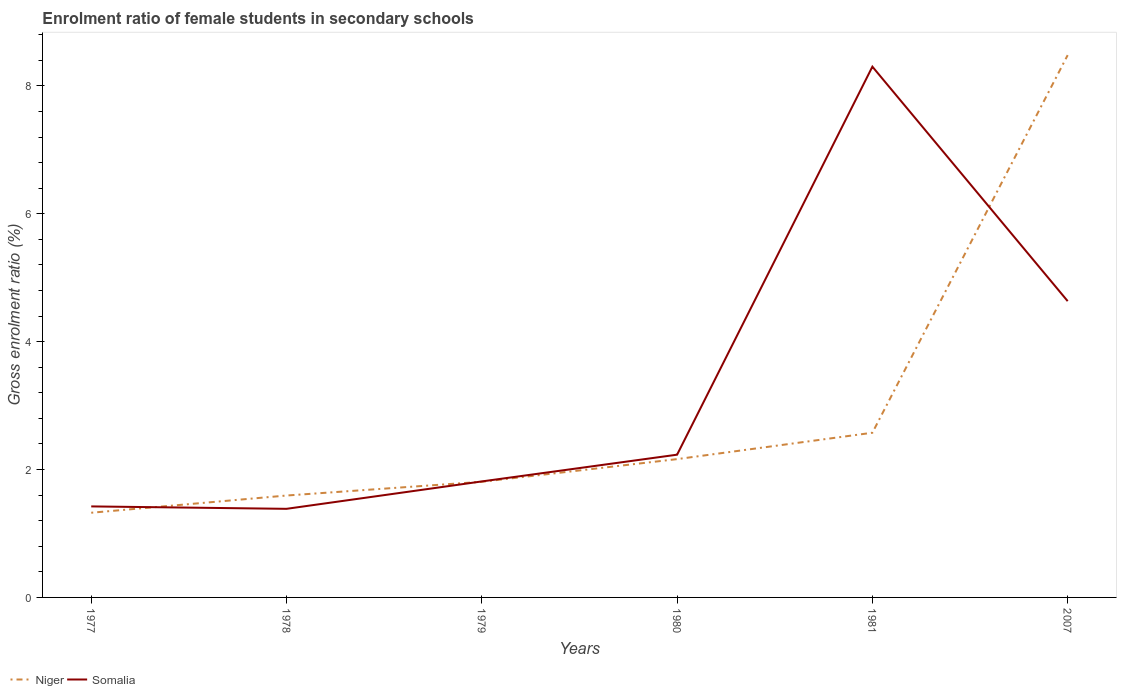Is the number of lines equal to the number of legend labels?
Your response must be concise. Yes. Across all years, what is the maximum enrolment ratio of female students in secondary schools in Niger?
Offer a terse response. 1.32. In which year was the enrolment ratio of female students in secondary schools in Somalia maximum?
Ensure brevity in your answer.  1978. What is the total enrolment ratio of female students in secondary schools in Somalia in the graph?
Offer a terse response. -0.43. What is the difference between the highest and the second highest enrolment ratio of female students in secondary schools in Niger?
Make the answer very short. 7.16. What is the difference between two consecutive major ticks on the Y-axis?
Your answer should be compact. 2. Does the graph contain grids?
Your answer should be very brief. No. How are the legend labels stacked?
Your response must be concise. Horizontal. What is the title of the graph?
Offer a terse response. Enrolment ratio of female students in secondary schools. What is the label or title of the X-axis?
Keep it short and to the point. Years. What is the label or title of the Y-axis?
Offer a very short reply. Gross enrolment ratio (%). What is the Gross enrolment ratio (%) of Niger in 1977?
Offer a terse response. 1.32. What is the Gross enrolment ratio (%) in Somalia in 1977?
Give a very brief answer. 1.42. What is the Gross enrolment ratio (%) in Niger in 1978?
Provide a succinct answer. 1.59. What is the Gross enrolment ratio (%) in Somalia in 1978?
Your answer should be very brief. 1.39. What is the Gross enrolment ratio (%) in Niger in 1979?
Your response must be concise. 1.81. What is the Gross enrolment ratio (%) of Somalia in 1979?
Provide a succinct answer. 1.81. What is the Gross enrolment ratio (%) in Niger in 1980?
Ensure brevity in your answer.  2.16. What is the Gross enrolment ratio (%) in Somalia in 1980?
Your answer should be compact. 2.23. What is the Gross enrolment ratio (%) of Niger in 1981?
Your answer should be compact. 2.58. What is the Gross enrolment ratio (%) in Somalia in 1981?
Give a very brief answer. 8.3. What is the Gross enrolment ratio (%) of Niger in 2007?
Give a very brief answer. 8.48. What is the Gross enrolment ratio (%) in Somalia in 2007?
Your answer should be very brief. 4.63. Across all years, what is the maximum Gross enrolment ratio (%) in Niger?
Ensure brevity in your answer.  8.48. Across all years, what is the maximum Gross enrolment ratio (%) in Somalia?
Your response must be concise. 8.3. Across all years, what is the minimum Gross enrolment ratio (%) of Niger?
Provide a short and direct response. 1.32. Across all years, what is the minimum Gross enrolment ratio (%) of Somalia?
Make the answer very short. 1.39. What is the total Gross enrolment ratio (%) in Niger in the graph?
Your answer should be very brief. 17.95. What is the total Gross enrolment ratio (%) of Somalia in the graph?
Provide a succinct answer. 19.79. What is the difference between the Gross enrolment ratio (%) in Niger in 1977 and that in 1978?
Offer a very short reply. -0.27. What is the difference between the Gross enrolment ratio (%) of Somalia in 1977 and that in 1978?
Offer a terse response. 0.04. What is the difference between the Gross enrolment ratio (%) of Niger in 1977 and that in 1979?
Make the answer very short. -0.48. What is the difference between the Gross enrolment ratio (%) in Somalia in 1977 and that in 1979?
Make the answer very short. -0.39. What is the difference between the Gross enrolment ratio (%) in Niger in 1977 and that in 1980?
Provide a succinct answer. -0.84. What is the difference between the Gross enrolment ratio (%) in Somalia in 1977 and that in 1980?
Offer a very short reply. -0.81. What is the difference between the Gross enrolment ratio (%) of Niger in 1977 and that in 1981?
Ensure brevity in your answer.  -1.25. What is the difference between the Gross enrolment ratio (%) of Somalia in 1977 and that in 1981?
Offer a very short reply. -6.88. What is the difference between the Gross enrolment ratio (%) in Niger in 1977 and that in 2007?
Your response must be concise. -7.16. What is the difference between the Gross enrolment ratio (%) of Somalia in 1977 and that in 2007?
Your response must be concise. -3.21. What is the difference between the Gross enrolment ratio (%) in Niger in 1978 and that in 1979?
Make the answer very short. -0.21. What is the difference between the Gross enrolment ratio (%) in Somalia in 1978 and that in 1979?
Your answer should be very brief. -0.43. What is the difference between the Gross enrolment ratio (%) of Niger in 1978 and that in 1980?
Make the answer very short. -0.57. What is the difference between the Gross enrolment ratio (%) of Somalia in 1978 and that in 1980?
Provide a succinct answer. -0.85. What is the difference between the Gross enrolment ratio (%) in Niger in 1978 and that in 1981?
Give a very brief answer. -0.98. What is the difference between the Gross enrolment ratio (%) of Somalia in 1978 and that in 1981?
Give a very brief answer. -6.92. What is the difference between the Gross enrolment ratio (%) of Niger in 1978 and that in 2007?
Your response must be concise. -6.89. What is the difference between the Gross enrolment ratio (%) in Somalia in 1978 and that in 2007?
Give a very brief answer. -3.25. What is the difference between the Gross enrolment ratio (%) of Niger in 1979 and that in 1980?
Your response must be concise. -0.35. What is the difference between the Gross enrolment ratio (%) in Somalia in 1979 and that in 1980?
Make the answer very short. -0.42. What is the difference between the Gross enrolment ratio (%) in Niger in 1979 and that in 1981?
Give a very brief answer. -0.77. What is the difference between the Gross enrolment ratio (%) in Somalia in 1979 and that in 1981?
Offer a very short reply. -6.49. What is the difference between the Gross enrolment ratio (%) in Niger in 1979 and that in 2007?
Ensure brevity in your answer.  -6.67. What is the difference between the Gross enrolment ratio (%) of Somalia in 1979 and that in 2007?
Offer a terse response. -2.82. What is the difference between the Gross enrolment ratio (%) of Niger in 1980 and that in 1981?
Make the answer very short. -0.41. What is the difference between the Gross enrolment ratio (%) in Somalia in 1980 and that in 1981?
Offer a very short reply. -6.07. What is the difference between the Gross enrolment ratio (%) in Niger in 1980 and that in 2007?
Ensure brevity in your answer.  -6.32. What is the difference between the Gross enrolment ratio (%) of Somalia in 1980 and that in 2007?
Provide a succinct answer. -2.4. What is the difference between the Gross enrolment ratio (%) of Niger in 1981 and that in 2007?
Provide a short and direct response. -5.91. What is the difference between the Gross enrolment ratio (%) in Somalia in 1981 and that in 2007?
Your response must be concise. 3.67. What is the difference between the Gross enrolment ratio (%) of Niger in 1977 and the Gross enrolment ratio (%) of Somalia in 1978?
Keep it short and to the point. -0.06. What is the difference between the Gross enrolment ratio (%) of Niger in 1977 and the Gross enrolment ratio (%) of Somalia in 1979?
Offer a very short reply. -0.49. What is the difference between the Gross enrolment ratio (%) in Niger in 1977 and the Gross enrolment ratio (%) in Somalia in 1980?
Offer a terse response. -0.91. What is the difference between the Gross enrolment ratio (%) of Niger in 1977 and the Gross enrolment ratio (%) of Somalia in 1981?
Provide a succinct answer. -6.98. What is the difference between the Gross enrolment ratio (%) in Niger in 1977 and the Gross enrolment ratio (%) in Somalia in 2007?
Offer a terse response. -3.31. What is the difference between the Gross enrolment ratio (%) of Niger in 1978 and the Gross enrolment ratio (%) of Somalia in 1979?
Make the answer very short. -0.22. What is the difference between the Gross enrolment ratio (%) of Niger in 1978 and the Gross enrolment ratio (%) of Somalia in 1980?
Provide a short and direct response. -0.64. What is the difference between the Gross enrolment ratio (%) in Niger in 1978 and the Gross enrolment ratio (%) in Somalia in 1981?
Keep it short and to the point. -6.71. What is the difference between the Gross enrolment ratio (%) in Niger in 1978 and the Gross enrolment ratio (%) in Somalia in 2007?
Provide a short and direct response. -3.04. What is the difference between the Gross enrolment ratio (%) in Niger in 1979 and the Gross enrolment ratio (%) in Somalia in 1980?
Your answer should be very brief. -0.42. What is the difference between the Gross enrolment ratio (%) of Niger in 1979 and the Gross enrolment ratio (%) of Somalia in 1981?
Your answer should be very brief. -6.49. What is the difference between the Gross enrolment ratio (%) in Niger in 1979 and the Gross enrolment ratio (%) in Somalia in 2007?
Ensure brevity in your answer.  -2.83. What is the difference between the Gross enrolment ratio (%) of Niger in 1980 and the Gross enrolment ratio (%) of Somalia in 1981?
Your response must be concise. -6.14. What is the difference between the Gross enrolment ratio (%) in Niger in 1980 and the Gross enrolment ratio (%) in Somalia in 2007?
Provide a succinct answer. -2.47. What is the difference between the Gross enrolment ratio (%) of Niger in 1981 and the Gross enrolment ratio (%) of Somalia in 2007?
Make the answer very short. -2.06. What is the average Gross enrolment ratio (%) in Niger per year?
Keep it short and to the point. 2.99. What is the average Gross enrolment ratio (%) in Somalia per year?
Provide a succinct answer. 3.3. In the year 1977, what is the difference between the Gross enrolment ratio (%) in Niger and Gross enrolment ratio (%) in Somalia?
Offer a terse response. -0.1. In the year 1978, what is the difference between the Gross enrolment ratio (%) of Niger and Gross enrolment ratio (%) of Somalia?
Keep it short and to the point. 0.21. In the year 1979, what is the difference between the Gross enrolment ratio (%) in Niger and Gross enrolment ratio (%) in Somalia?
Give a very brief answer. -0.01. In the year 1980, what is the difference between the Gross enrolment ratio (%) in Niger and Gross enrolment ratio (%) in Somalia?
Your answer should be compact. -0.07. In the year 1981, what is the difference between the Gross enrolment ratio (%) of Niger and Gross enrolment ratio (%) of Somalia?
Keep it short and to the point. -5.73. In the year 2007, what is the difference between the Gross enrolment ratio (%) of Niger and Gross enrolment ratio (%) of Somalia?
Keep it short and to the point. 3.85. What is the ratio of the Gross enrolment ratio (%) of Niger in 1977 to that in 1978?
Ensure brevity in your answer.  0.83. What is the ratio of the Gross enrolment ratio (%) of Somalia in 1977 to that in 1978?
Your answer should be very brief. 1.03. What is the ratio of the Gross enrolment ratio (%) of Niger in 1977 to that in 1979?
Provide a succinct answer. 0.73. What is the ratio of the Gross enrolment ratio (%) in Somalia in 1977 to that in 1979?
Ensure brevity in your answer.  0.78. What is the ratio of the Gross enrolment ratio (%) of Niger in 1977 to that in 1980?
Your response must be concise. 0.61. What is the ratio of the Gross enrolment ratio (%) of Somalia in 1977 to that in 1980?
Make the answer very short. 0.64. What is the ratio of the Gross enrolment ratio (%) of Niger in 1977 to that in 1981?
Ensure brevity in your answer.  0.51. What is the ratio of the Gross enrolment ratio (%) of Somalia in 1977 to that in 1981?
Provide a succinct answer. 0.17. What is the ratio of the Gross enrolment ratio (%) in Niger in 1977 to that in 2007?
Your answer should be very brief. 0.16. What is the ratio of the Gross enrolment ratio (%) of Somalia in 1977 to that in 2007?
Offer a very short reply. 0.31. What is the ratio of the Gross enrolment ratio (%) of Niger in 1978 to that in 1979?
Keep it short and to the point. 0.88. What is the ratio of the Gross enrolment ratio (%) in Somalia in 1978 to that in 1979?
Your response must be concise. 0.76. What is the ratio of the Gross enrolment ratio (%) in Niger in 1978 to that in 1980?
Give a very brief answer. 0.74. What is the ratio of the Gross enrolment ratio (%) of Somalia in 1978 to that in 1980?
Your answer should be very brief. 0.62. What is the ratio of the Gross enrolment ratio (%) of Niger in 1978 to that in 1981?
Give a very brief answer. 0.62. What is the ratio of the Gross enrolment ratio (%) in Somalia in 1978 to that in 1981?
Offer a terse response. 0.17. What is the ratio of the Gross enrolment ratio (%) of Niger in 1978 to that in 2007?
Provide a short and direct response. 0.19. What is the ratio of the Gross enrolment ratio (%) of Somalia in 1978 to that in 2007?
Offer a very short reply. 0.3. What is the ratio of the Gross enrolment ratio (%) of Niger in 1979 to that in 1980?
Offer a terse response. 0.84. What is the ratio of the Gross enrolment ratio (%) of Somalia in 1979 to that in 1980?
Give a very brief answer. 0.81. What is the ratio of the Gross enrolment ratio (%) of Niger in 1979 to that in 1981?
Provide a succinct answer. 0.7. What is the ratio of the Gross enrolment ratio (%) in Somalia in 1979 to that in 1981?
Provide a short and direct response. 0.22. What is the ratio of the Gross enrolment ratio (%) of Niger in 1979 to that in 2007?
Your answer should be compact. 0.21. What is the ratio of the Gross enrolment ratio (%) in Somalia in 1979 to that in 2007?
Your answer should be very brief. 0.39. What is the ratio of the Gross enrolment ratio (%) in Niger in 1980 to that in 1981?
Your answer should be very brief. 0.84. What is the ratio of the Gross enrolment ratio (%) of Somalia in 1980 to that in 1981?
Your response must be concise. 0.27. What is the ratio of the Gross enrolment ratio (%) of Niger in 1980 to that in 2007?
Give a very brief answer. 0.26. What is the ratio of the Gross enrolment ratio (%) of Somalia in 1980 to that in 2007?
Your answer should be compact. 0.48. What is the ratio of the Gross enrolment ratio (%) in Niger in 1981 to that in 2007?
Your answer should be compact. 0.3. What is the ratio of the Gross enrolment ratio (%) of Somalia in 1981 to that in 2007?
Ensure brevity in your answer.  1.79. What is the difference between the highest and the second highest Gross enrolment ratio (%) of Niger?
Provide a short and direct response. 5.91. What is the difference between the highest and the second highest Gross enrolment ratio (%) of Somalia?
Provide a short and direct response. 3.67. What is the difference between the highest and the lowest Gross enrolment ratio (%) in Niger?
Keep it short and to the point. 7.16. What is the difference between the highest and the lowest Gross enrolment ratio (%) in Somalia?
Offer a very short reply. 6.92. 